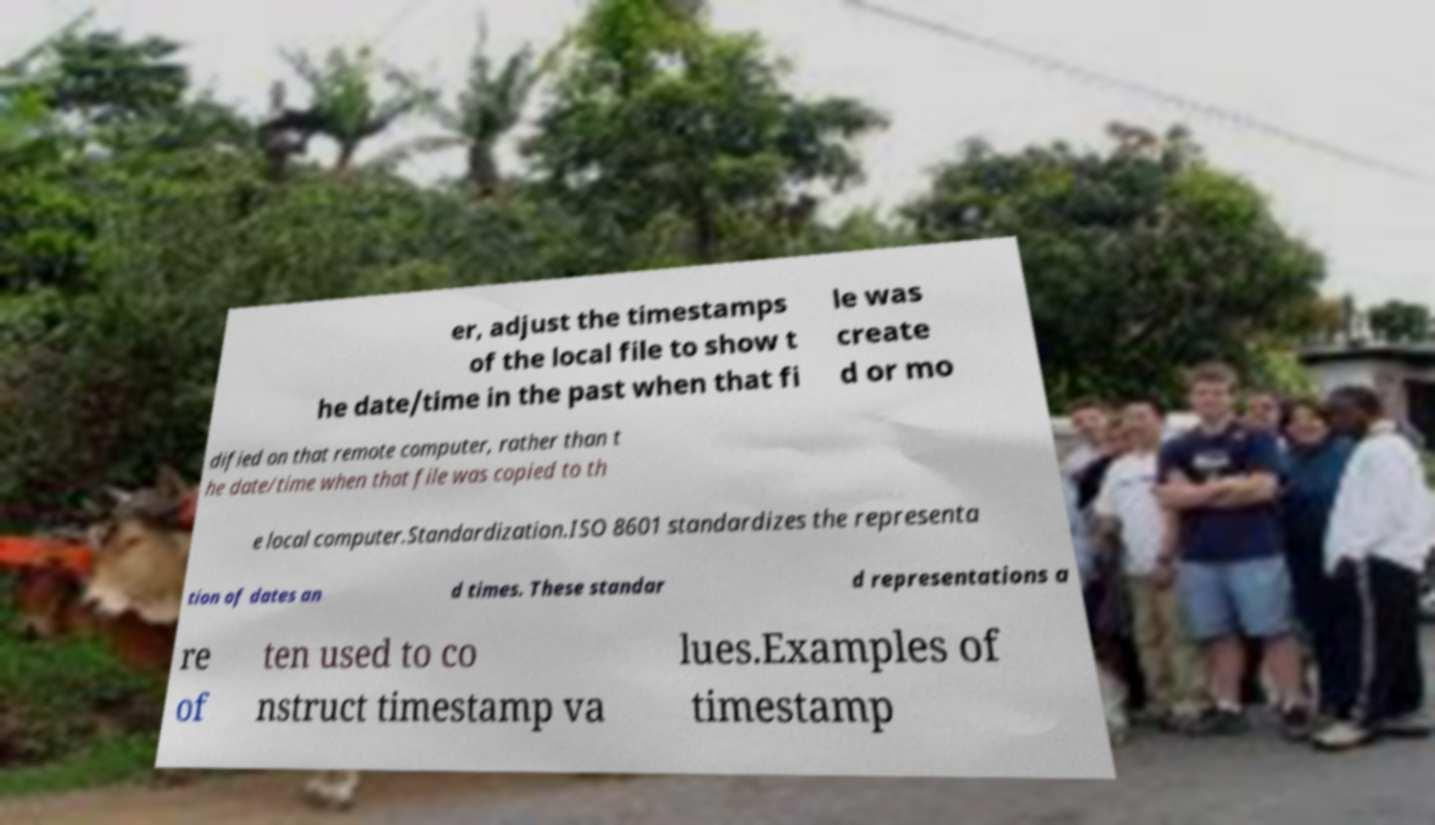What messages or text are displayed in this image? I need them in a readable, typed format. er, adjust the timestamps of the local file to show t he date/time in the past when that fi le was create d or mo dified on that remote computer, rather than t he date/time when that file was copied to th e local computer.Standardization.ISO 8601 standardizes the representa tion of dates an d times. These standar d representations a re of ten used to co nstruct timestamp va lues.Examples of timestamp 